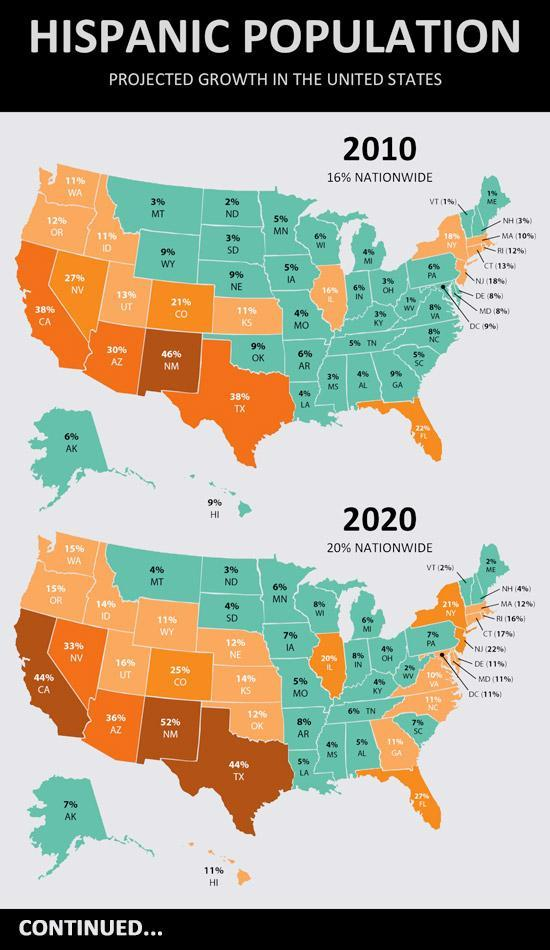What is the difference between the Hispanic population of MO in 2020 and 2010?
Answer the question with a short phrase. 1% What is the difference between the Hispanic population of NE in 2020 and 2010? 3% What is the difference between the Hispanic population of ND in 2020 and 2010? 1% What is the difference between the Hispanic population of MT in 2020 and 2010? 1% What is the difference between the Hispanic population of TX in 2020 and 2010? 6% 